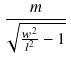<formula> <loc_0><loc_0><loc_500><loc_500>\frac { m } { \sqrt { \frac { w ^ { 2 } } { l ^ { 2 } } - 1 } }</formula> 